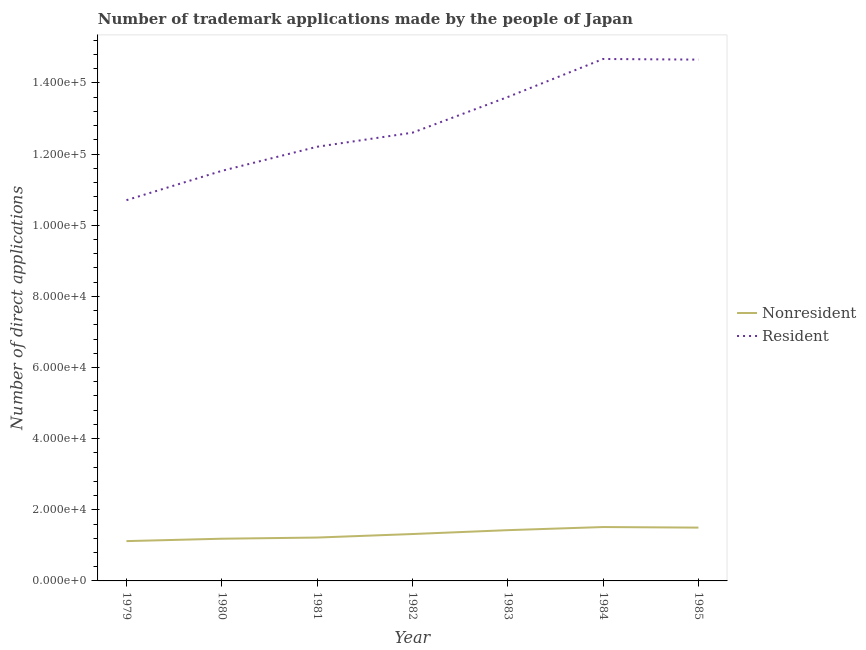How many different coloured lines are there?
Give a very brief answer. 2. Does the line corresponding to number of trademark applications made by residents intersect with the line corresponding to number of trademark applications made by non residents?
Ensure brevity in your answer.  No. Is the number of lines equal to the number of legend labels?
Ensure brevity in your answer.  Yes. What is the number of trademark applications made by non residents in 1983?
Your response must be concise. 1.43e+04. Across all years, what is the maximum number of trademark applications made by residents?
Offer a terse response. 1.47e+05. Across all years, what is the minimum number of trademark applications made by non residents?
Your answer should be very brief. 1.12e+04. In which year was the number of trademark applications made by non residents minimum?
Provide a succinct answer. 1979. What is the total number of trademark applications made by residents in the graph?
Make the answer very short. 9.00e+05. What is the difference between the number of trademark applications made by non residents in 1981 and that in 1982?
Your answer should be compact. -992. What is the difference between the number of trademark applications made by non residents in 1979 and the number of trademark applications made by residents in 1981?
Offer a very short reply. -1.11e+05. What is the average number of trademark applications made by non residents per year?
Give a very brief answer. 1.33e+04. In the year 1984, what is the difference between the number of trademark applications made by residents and number of trademark applications made by non residents?
Keep it short and to the point. 1.32e+05. What is the ratio of the number of trademark applications made by residents in 1981 to that in 1984?
Your response must be concise. 0.83. Is the number of trademark applications made by non residents in 1980 less than that in 1982?
Your answer should be compact. Yes. Is the difference between the number of trademark applications made by residents in 1983 and 1984 greater than the difference between the number of trademark applications made by non residents in 1983 and 1984?
Keep it short and to the point. No. What is the difference between the highest and the second highest number of trademark applications made by non residents?
Provide a short and direct response. 159. What is the difference between the highest and the lowest number of trademark applications made by residents?
Provide a succinct answer. 3.97e+04. Is the sum of the number of trademark applications made by residents in 1980 and 1981 greater than the maximum number of trademark applications made by non residents across all years?
Ensure brevity in your answer.  Yes. Does the number of trademark applications made by non residents monotonically increase over the years?
Provide a short and direct response. No. Is the number of trademark applications made by residents strictly less than the number of trademark applications made by non residents over the years?
Make the answer very short. No. How many years are there in the graph?
Make the answer very short. 7. Are the values on the major ticks of Y-axis written in scientific E-notation?
Your response must be concise. Yes. Does the graph contain grids?
Ensure brevity in your answer.  No. Where does the legend appear in the graph?
Your response must be concise. Center right. How many legend labels are there?
Offer a very short reply. 2. How are the legend labels stacked?
Give a very brief answer. Vertical. What is the title of the graph?
Provide a short and direct response. Number of trademark applications made by the people of Japan. What is the label or title of the X-axis?
Your answer should be compact. Year. What is the label or title of the Y-axis?
Offer a terse response. Number of direct applications. What is the Number of direct applications of Nonresident in 1979?
Give a very brief answer. 1.12e+04. What is the Number of direct applications of Resident in 1979?
Offer a terse response. 1.07e+05. What is the Number of direct applications in Nonresident in 1980?
Give a very brief answer. 1.19e+04. What is the Number of direct applications in Resident in 1980?
Offer a very short reply. 1.15e+05. What is the Number of direct applications of Nonresident in 1981?
Provide a succinct answer. 1.22e+04. What is the Number of direct applications in Resident in 1981?
Your answer should be very brief. 1.22e+05. What is the Number of direct applications in Nonresident in 1982?
Your answer should be compact. 1.32e+04. What is the Number of direct applications in Resident in 1982?
Give a very brief answer. 1.26e+05. What is the Number of direct applications in Nonresident in 1983?
Provide a short and direct response. 1.43e+04. What is the Number of direct applications in Resident in 1983?
Ensure brevity in your answer.  1.36e+05. What is the Number of direct applications of Nonresident in 1984?
Your answer should be compact. 1.51e+04. What is the Number of direct applications of Resident in 1984?
Your answer should be compact. 1.47e+05. What is the Number of direct applications in Nonresident in 1985?
Provide a short and direct response. 1.50e+04. What is the Number of direct applications in Resident in 1985?
Give a very brief answer. 1.47e+05. Across all years, what is the maximum Number of direct applications in Nonresident?
Ensure brevity in your answer.  1.51e+04. Across all years, what is the maximum Number of direct applications in Resident?
Your answer should be compact. 1.47e+05. Across all years, what is the minimum Number of direct applications in Nonresident?
Your answer should be very brief. 1.12e+04. Across all years, what is the minimum Number of direct applications in Resident?
Keep it short and to the point. 1.07e+05. What is the total Number of direct applications in Nonresident in the graph?
Make the answer very short. 9.28e+04. What is the total Number of direct applications of Resident in the graph?
Keep it short and to the point. 9.00e+05. What is the difference between the Number of direct applications of Nonresident in 1979 and that in 1980?
Offer a very short reply. -673. What is the difference between the Number of direct applications in Resident in 1979 and that in 1980?
Your answer should be compact. -8243. What is the difference between the Number of direct applications in Nonresident in 1979 and that in 1981?
Give a very brief answer. -999. What is the difference between the Number of direct applications of Resident in 1979 and that in 1981?
Your answer should be very brief. -1.50e+04. What is the difference between the Number of direct applications of Nonresident in 1979 and that in 1982?
Offer a very short reply. -1991. What is the difference between the Number of direct applications of Resident in 1979 and that in 1982?
Your answer should be very brief. -1.90e+04. What is the difference between the Number of direct applications of Nonresident in 1979 and that in 1983?
Keep it short and to the point. -3080. What is the difference between the Number of direct applications of Resident in 1979 and that in 1983?
Offer a very short reply. -2.90e+04. What is the difference between the Number of direct applications of Nonresident in 1979 and that in 1984?
Your response must be concise. -3955. What is the difference between the Number of direct applications of Resident in 1979 and that in 1984?
Offer a very short reply. -3.97e+04. What is the difference between the Number of direct applications of Nonresident in 1979 and that in 1985?
Provide a short and direct response. -3796. What is the difference between the Number of direct applications in Resident in 1979 and that in 1985?
Provide a succinct answer. -3.95e+04. What is the difference between the Number of direct applications of Nonresident in 1980 and that in 1981?
Your answer should be very brief. -326. What is the difference between the Number of direct applications in Resident in 1980 and that in 1981?
Your answer should be very brief. -6774. What is the difference between the Number of direct applications of Nonresident in 1980 and that in 1982?
Provide a short and direct response. -1318. What is the difference between the Number of direct applications of Resident in 1980 and that in 1982?
Your answer should be very brief. -1.07e+04. What is the difference between the Number of direct applications in Nonresident in 1980 and that in 1983?
Provide a short and direct response. -2407. What is the difference between the Number of direct applications of Resident in 1980 and that in 1983?
Your answer should be very brief. -2.08e+04. What is the difference between the Number of direct applications of Nonresident in 1980 and that in 1984?
Keep it short and to the point. -3282. What is the difference between the Number of direct applications of Resident in 1980 and that in 1984?
Your answer should be compact. -3.14e+04. What is the difference between the Number of direct applications in Nonresident in 1980 and that in 1985?
Provide a short and direct response. -3123. What is the difference between the Number of direct applications in Resident in 1980 and that in 1985?
Your answer should be very brief. -3.13e+04. What is the difference between the Number of direct applications in Nonresident in 1981 and that in 1982?
Keep it short and to the point. -992. What is the difference between the Number of direct applications of Resident in 1981 and that in 1982?
Offer a very short reply. -3955. What is the difference between the Number of direct applications of Nonresident in 1981 and that in 1983?
Ensure brevity in your answer.  -2081. What is the difference between the Number of direct applications in Resident in 1981 and that in 1983?
Your answer should be very brief. -1.40e+04. What is the difference between the Number of direct applications of Nonresident in 1981 and that in 1984?
Offer a terse response. -2956. What is the difference between the Number of direct applications of Resident in 1981 and that in 1984?
Provide a succinct answer. -2.47e+04. What is the difference between the Number of direct applications of Nonresident in 1981 and that in 1985?
Ensure brevity in your answer.  -2797. What is the difference between the Number of direct applications of Resident in 1981 and that in 1985?
Keep it short and to the point. -2.45e+04. What is the difference between the Number of direct applications of Nonresident in 1982 and that in 1983?
Give a very brief answer. -1089. What is the difference between the Number of direct applications in Resident in 1982 and that in 1983?
Your response must be concise. -1.00e+04. What is the difference between the Number of direct applications in Nonresident in 1982 and that in 1984?
Your answer should be very brief. -1964. What is the difference between the Number of direct applications in Resident in 1982 and that in 1984?
Your answer should be compact. -2.07e+04. What is the difference between the Number of direct applications in Nonresident in 1982 and that in 1985?
Give a very brief answer. -1805. What is the difference between the Number of direct applications of Resident in 1982 and that in 1985?
Give a very brief answer. -2.05e+04. What is the difference between the Number of direct applications of Nonresident in 1983 and that in 1984?
Your answer should be very brief. -875. What is the difference between the Number of direct applications of Resident in 1983 and that in 1984?
Your answer should be compact. -1.07e+04. What is the difference between the Number of direct applications in Nonresident in 1983 and that in 1985?
Offer a terse response. -716. What is the difference between the Number of direct applications of Resident in 1983 and that in 1985?
Make the answer very short. -1.05e+04. What is the difference between the Number of direct applications in Nonresident in 1984 and that in 1985?
Ensure brevity in your answer.  159. What is the difference between the Number of direct applications of Resident in 1984 and that in 1985?
Offer a very short reply. 177. What is the difference between the Number of direct applications in Nonresident in 1979 and the Number of direct applications in Resident in 1980?
Offer a terse response. -1.04e+05. What is the difference between the Number of direct applications in Nonresident in 1979 and the Number of direct applications in Resident in 1981?
Your answer should be very brief. -1.11e+05. What is the difference between the Number of direct applications of Nonresident in 1979 and the Number of direct applications of Resident in 1982?
Provide a short and direct response. -1.15e+05. What is the difference between the Number of direct applications of Nonresident in 1979 and the Number of direct applications of Resident in 1983?
Offer a very short reply. -1.25e+05. What is the difference between the Number of direct applications in Nonresident in 1979 and the Number of direct applications in Resident in 1984?
Offer a terse response. -1.36e+05. What is the difference between the Number of direct applications in Nonresident in 1979 and the Number of direct applications in Resident in 1985?
Your answer should be compact. -1.35e+05. What is the difference between the Number of direct applications in Nonresident in 1980 and the Number of direct applications in Resident in 1981?
Your answer should be very brief. -1.10e+05. What is the difference between the Number of direct applications of Nonresident in 1980 and the Number of direct applications of Resident in 1982?
Make the answer very short. -1.14e+05. What is the difference between the Number of direct applications in Nonresident in 1980 and the Number of direct applications in Resident in 1983?
Ensure brevity in your answer.  -1.24e+05. What is the difference between the Number of direct applications of Nonresident in 1980 and the Number of direct applications of Resident in 1984?
Make the answer very short. -1.35e+05. What is the difference between the Number of direct applications of Nonresident in 1980 and the Number of direct applications of Resident in 1985?
Make the answer very short. -1.35e+05. What is the difference between the Number of direct applications of Nonresident in 1981 and the Number of direct applications of Resident in 1982?
Offer a terse response. -1.14e+05. What is the difference between the Number of direct applications of Nonresident in 1981 and the Number of direct applications of Resident in 1983?
Give a very brief answer. -1.24e+05. What is the difference between the Number of direct applications of Nonresident in 1981 and the Number of direct applications of Resident in 1984?
Your response must be concise. -1.35e+05. What is the difference between the Number of direct applications of Nonresident in 1981 and the Number of direct applications of Resident in 1985?
Your answer should be compact. -1.34e+05. What is the difference between the Number of direct applications in Nonresident in 1982 and the Number of direct applications in Resident in 1983?
Provide a short and direct response. -1.23e+05. What is the difference between the Number of direct applications of Nonresident in 1982 and the Number of direct applications of Resident in 1984?
Ensure brevity in your answer.  -1.34e+05. What is the difference between the Number of direct applications of Nonresident in 1982 and the Number of direct applications of Resident in 1985?
Your answer should be compact. -1.33e+05. What is the difference between the Number of direct applications in Nonresident in 1983 and the Number of direct applications in Resident in 1984?
Offer a very short reply. -1.32e+05. What is the difference between the Number of direct applications in Nonresident in 1983 and the Number of direct applications in Resident in 1985?
Provide a short and direct response. -1.32e+05. What is the difference between the Number of direct applications in Nonresident in 1984 and the Number of direct applications in Resident in 1985?
Offer a very short reply. -1.31e+05. What is the average Number of direct applications in Nonresident per year?
Provide a succinct answer. 1.33e+04. What is the average Number of direct applications in Resident per year?
Your response must be concise. 1.29e+05. In the year 1979, what is the difference between the Number of direct applications of Nonresident and Number of direct applications of Resident?
Your response must be concise. -9.58e+04. In the year 1980, what is the difference between the Number of direct applications of Nonresident and Number of direct applications of Resident?
Your response must be concise. -1.03e+05. In the year 1981, what is the difference between the Number of direct applications of Nonresident and Number of direct applications of Resident?
Make the answer very short. -1.10e+05. In the year 1982, what is the difference between the Number of direct applications in Nonresident and Number of direct applications in Resident?
Provide a short and direct response. -1.13e+05. In the year 1983, what is the difference between the Number of direct applications in Nonresident and Number of direct applications in Resident?
Your answer should be compact. -1.22e+05. In the year 1984, what is the difference between the Number of direct applications of Nonresident and Number of direct applications of Resident?
Keep it short and to the point. -1.32e+05. In the year 1985, what is the difference between the Number of direct applications in Nonresident and Number of direct applications in Resident?
Provide a short and direct response. -1.32e+05. What is the ratio of the Number of direct applications of Nonresident in 1979 to that in 1980?
Offer a very short reply. 0.94. What is the ratio of the Number of direct applications of Resident in 1979 to that in 1980?
Make the answer very short. 0.93. What is the ratio of the Number of direct applications of Nonresident in 1979 to that in 1981?
Your answer should be very brief. 0.92. What is the ratio of the Number of direct applications of Resident in 1979 to that in 1981?
Your response must be concise. 0.88. What is the ratio of the Number of direct applications of Nonresident in 1979 to that in 1982?
Offer a very short reply. 0.85. What is the ratio of the Number of direct applications in Resident in 1979 to that in 1982?
Give a very brief answer. 0.85. What is the ratio of the Number of direct applications of Nonresident in 1979 to that in 1983?
Give a very brief answer. 0.78. What is the ratio of the Number of direct applications in Resident in 1979 to that in 1983?
Offer a terse response. 0.79. What is the ratio of the Number of direct applications of Nonresident in 1979 to that in 1984?
Your answer should be very brief. 0.74. What is the ratio of the Number of direct applications in Resident in 1979 to that in 1984?
Offer a very short reply. 0.73. What is the ratio of the Number of direct applications in Nonresident in 1979 to that in 1985?
Make the answer very short. 0.75. What is the ratio of the Number of direct applications of Resident in 1979 to that in 1985?
Offer a terse response. 0.73. What is the ratio of the Number of direct applications in Nonresident in 1980 to that in 1981?
Your answer should be compact. 0.97. What is the ratio of the Number of direct applications of Resident in 1980 to that in 1981?
Offer a very short reply. 0.94. What is the ratio of the Number of direct applications of Resident in 1980 to that in 1982?
Your answer should be compact. 0.91. What is the ratio of the Number of direct applications of Nonresident in 1980 to that in 1983?
Offer a terse response. 0.83. What is the ratio of the Number of direct applications in Resident in 1980 to that in 1983?
Your response must be concise. 0.85. What is the ratio of the Number of direct applications in Nonresident in 1980 to that in 1984?
Make the answer very short. 0.78. What is the ratio of the Number of direct applications of Resident in 1980 to that in 1984?
Make the answer very short. 0.79. What is the ratio of the Number of direct applications of Nonresident in 1980 to that in 1985?
Offer a terse response. 0.79. What is the ratio of the Number of direct applications of Resident in 1980 to that in 1985?
Your answer should be very brief. 0.79. What is the ratio of the Number of direct applications of Nonresident in 1981 to that in 1982?
Your answer should be compact. 0.92. What is the ratio of the Number of direct applications in Resident in 1981 to that in 1982?
Ensure brevity in your answer.  0.97. What is the ratio of the Number of direct applications in Nonresident in 1981 to that in 1983?
Your response must be concise. 0.85. What is the ratio of the Number of direct applications in Resident in 1981 to that in 1983?
Your answer should be compact. 0.9. What is the ratio of the Number of direct applications in Nonresident in 1981 to that in 1984?
Your answer should be compact. 0.8. What is the ratio of the Number of direct applications of Resident in 1981 to that in 1984?
Offer a very short reply. 0.83. What is the ratio of the Number of direct applications in Nonresident in 1981 to that in 1985?
Provide a succinct answer. 0.81. What is the ratio of the Number of direct applications of Resident in 1981 to that in 1985?
Offer a very short reply. 0.83. What is the ratio of the Number of direct applications in Nonresident in 1982 to that in 1983?
Offer a terse response. 0.92. What is the ratio of the Number of direct applications of Resident in 1982 to that in 1983?
Offer a terse response. 0.93. What is the ratio of the Number of direct applications in Nonresident in 1982 to that in 1984?
Provide a succinct answer. 0.87. What is the ratio of the Number of direct applications in Resident in 1982 to that in 1984?
Give a very brief answer. 0.86. What is the ratio of the Number of direct applications in Nonresident in 1982 to that in 1985?
Offer a terse response. 0.88. What is the ratio of the Number of direct applications in Resident in 1982 to that in 1985?
Provide a short and direct response. 0.86. What is the ratio of the Number of direct applications in Nonresident in 1983 to that in 1984?
Give a very brief answer. 0.94. What is the ratio of the Number of direct applications in Resident in 1983 to that in 1984?
Provide a succinct answer. 0.93. What is the ratio of the Number of direct applications in Nonresident in 1983 to that in 1985?
Your answer should be compact. 0.95. What is the ratio of the Number of direct applications of Resident in 1983 to that in 1985?
Your response must be concise. 0.93. What is the ratio of the Number of direct applications in Nonresident in 1984 to that in 1985?
Provide a short and direct response. 1.01. What is the difference between the highest and the second highest Number of direct applications in Nonresident?
Your response must be concise. 159. What is the difference between the highest and the second highest Number of direct applications of Resident?
Your response must be concise. 177. What is the difference between the highest and the lowest Number of direct applications in Nonresident?
Provide a succinct answer. 3955. What is the difference between the highest and the lowest Number of direct applications in Resident?
Offer a very short reply. 3.97e+04. 